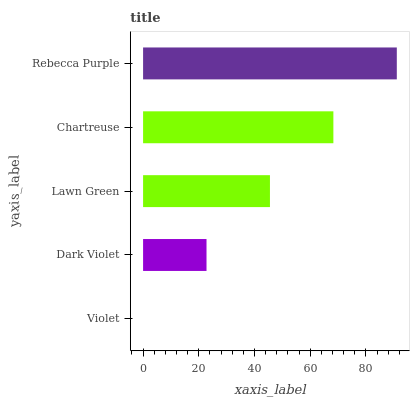Is Violet the minimum?
Answer yes or no. Yes. Is Rebecca Purple the maximum?
Answer yes or no. Yes. Is Dark Violet the minimum?
Answer yes or no. No. Is Dark Violet the maximum?
Answer yes or no. No. Is Dark Violet greater than Violet?
Answer yes or no. Yes. Is Violet less than Dark Violet?
Answer yes or no. Yes. Is Violet greater than Dark Violet?
Answer yes or no. No. Is Dark Violet less than Violet?
Answer yes or no. No. Is Lawn Green the high median?
Answer yes or no. Yes. Is Lawn Green the low median?
Answer yes or no. Yes. Is Chartreuse the high median?
Answer yes or no. No. Is Violet the low median?
Answer yes or no. No. 